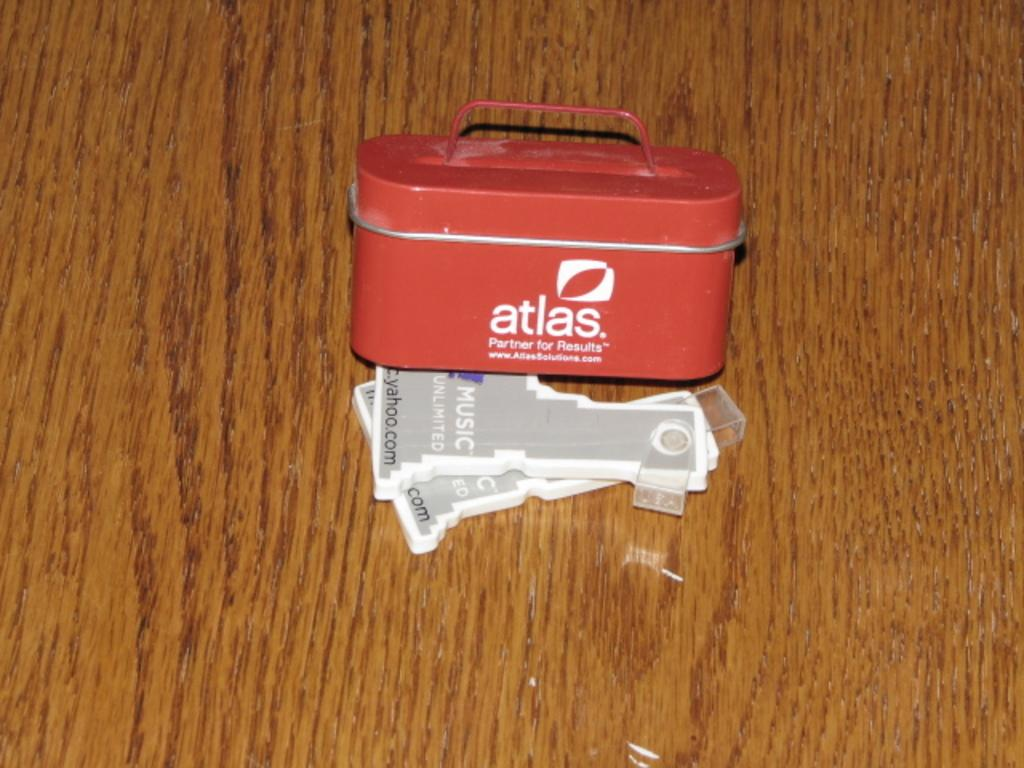Provide a one-sentence caption for the provided image. A small container that reads atlas on it. 